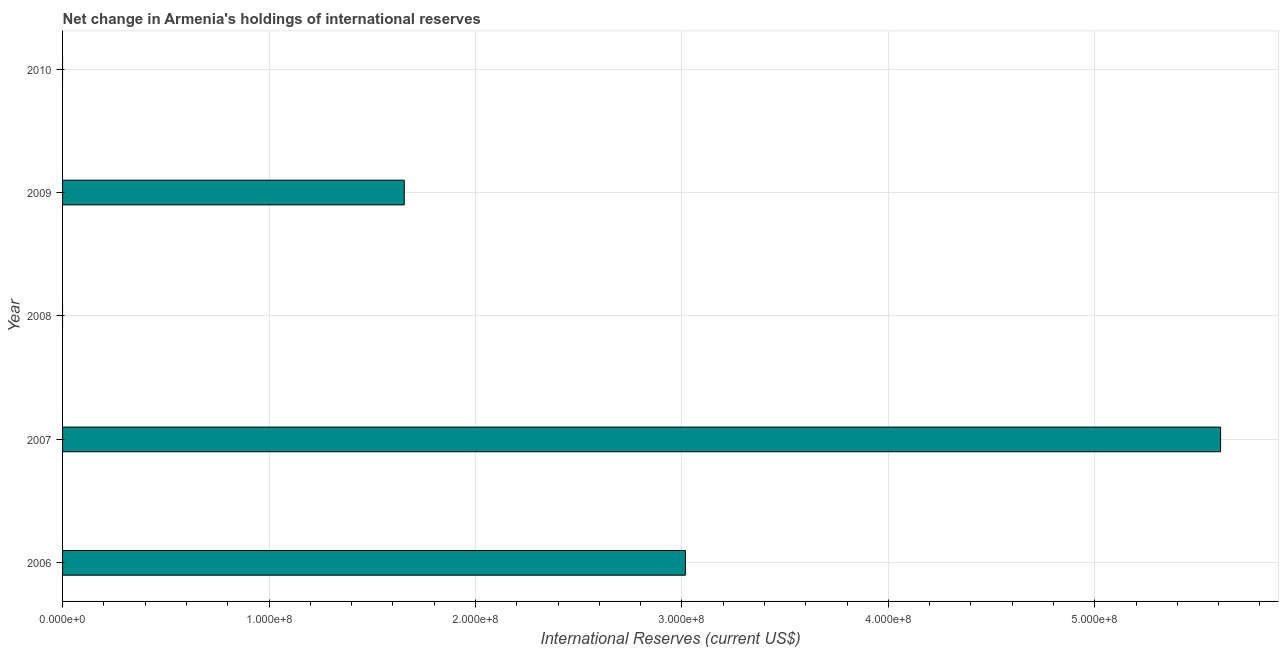Does the graph contain any zero values?
Provide a short and direct response. Yes. Does the graph contain grids?
Keep it short and to the point. Yes. What is the title of the graph?
Provide a succinct answer. Net change in Armenia's holdings of international reserves. What is the label or title of the X-axis?
Provide a short and direct response. International Reserves (current US$). What is the label or title of the Y-axis?
Keep it short and to the point. Year. What is the reserves and related items in 2009?
Ensure brevity in your answer.  1.66e+08. Across all years, what is the maximum reserves and related items?
Give a very brief answer. 5.61e+08. What is the sum of the reserves and related items?
Provide a short and direct response. 1.03e+09. What is the difference between the reserves and related items in 2006 and 2007?
Provide a short and direct response. -2.59e+08. What is the average reserves and related items per year?
Your response must be concise. 2.06e+08. What is the median reserves and related items?
Give a very brief answer. 1.66e+08. What is the ratio of the reserves and related items in 2006 to that in 2009?
Make the answer very short. 1.82. Is the reserves and related items in 2006 less than that in 2007?
Give a very brief answer. Yes. What is the difference between the highest and the second highest reserves and related items?
Your answer should be compact. 2.59e+08. Is the sum of the reserves and related items in 2007 and 2009 greater than the maximum reserves and related items across all years?
Offer a very short reply. Yes. What is the difference between the highest and the lowest reserves and related items?
Make the answer very short. 5.61e+08. In how many years, is the reserves and related items greater than the average reserves and related items taken over all years?
Keep it short and to the point. 2. Are all the bars in the graph horizontal?
Provide a succinct answer. Yes. How many years are there in the graph?
Give a very brief answer. 5. What is the International Reserves (current US$) of 2006?
Offer a terse response. 3.02e+08. What is the International Reserves (current US$) of 2007?
Offer a very short reply. 5.61e+08. What is the International Reserves (current US$) in 2008?
Provide a succinct answer. 0. What is the International Reserves (current US$) in 2009?
Make the answer very short. 1.66e+08. What is the International Reserves (current US$) in 2010?
Offer a terse response. 0. What is the difference between the International Reserves (current US$) in 2006 and 2007?
Your response must be concise. -2.59e+08. What is the difference between the International Reserves (current US$) in 2006 and 2009?
Keep it short and to the point. 1.36e+08. What is the difference between the International Reserves (current US$) in 2007 and 2009?
Your answer should be compact. 3.95e+08. What is the ratio of the International Reserves (current US$) in 2006 to that in 2007?
Your response must be concise. 0.54. What is the ratio of the International Reserves (current US$) in 2006 to that in 2009?
Your answer should be very brief. 1.82. What is the ratio of the International Reserves (current US$) in 2007 to that in 2009?
Make the answer very short. 3.39. 